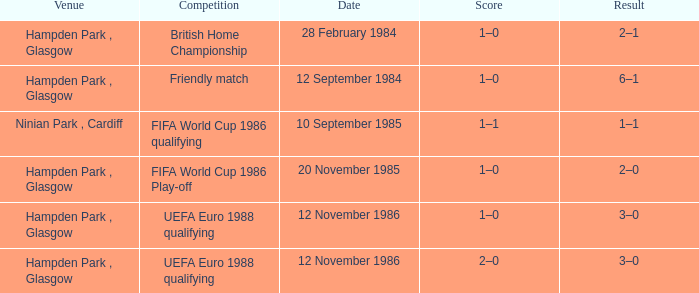Can you give me this table as a dict? {'header': ['Venue', 'Competition', 'Date', 'Score', 'Result'], 'rows': [['Hampden Park , Glasgow', 'British Home Championship', '28 February 1984', '1–0', '2–1'], ['Hampden Park , Glasgow', 'Friendly match', '12 September 1984', '1–0', '6–1'], ['Ninian Park , Cardiff', 'FIFA World Cup 1986 qualifying', '10 September 1985', '1–1', '1–1'], ['Hampden Park , Glasgow', 'FIFA World Cup 1986 Play-off', '20 November 1985', '1–0', '2–0'], ['Hampden Park , Glasgow', 'UEFA Euro 1988 qualifying', '12 November 1986', '1–0', '3–0'], ['Hampden Park , Glasgow', 'UEFA Euro 1988 qualifying', '12 November 1986', '2–0', '3–0']]} What is the Date of the Competition with a Result of 3–0? 12 November 1986, 12 November 1986. 